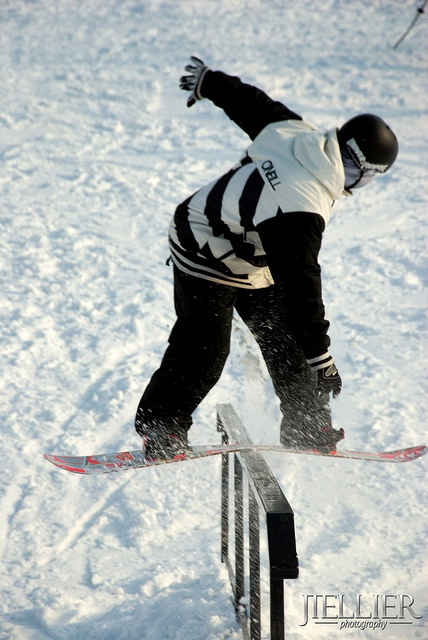Describe the objects in this image and their specific colors. I can see people in darkgray, black, gray, and lightgray tones and snowboard in darkgray, brown, gray, and lightpink tones in this image. 